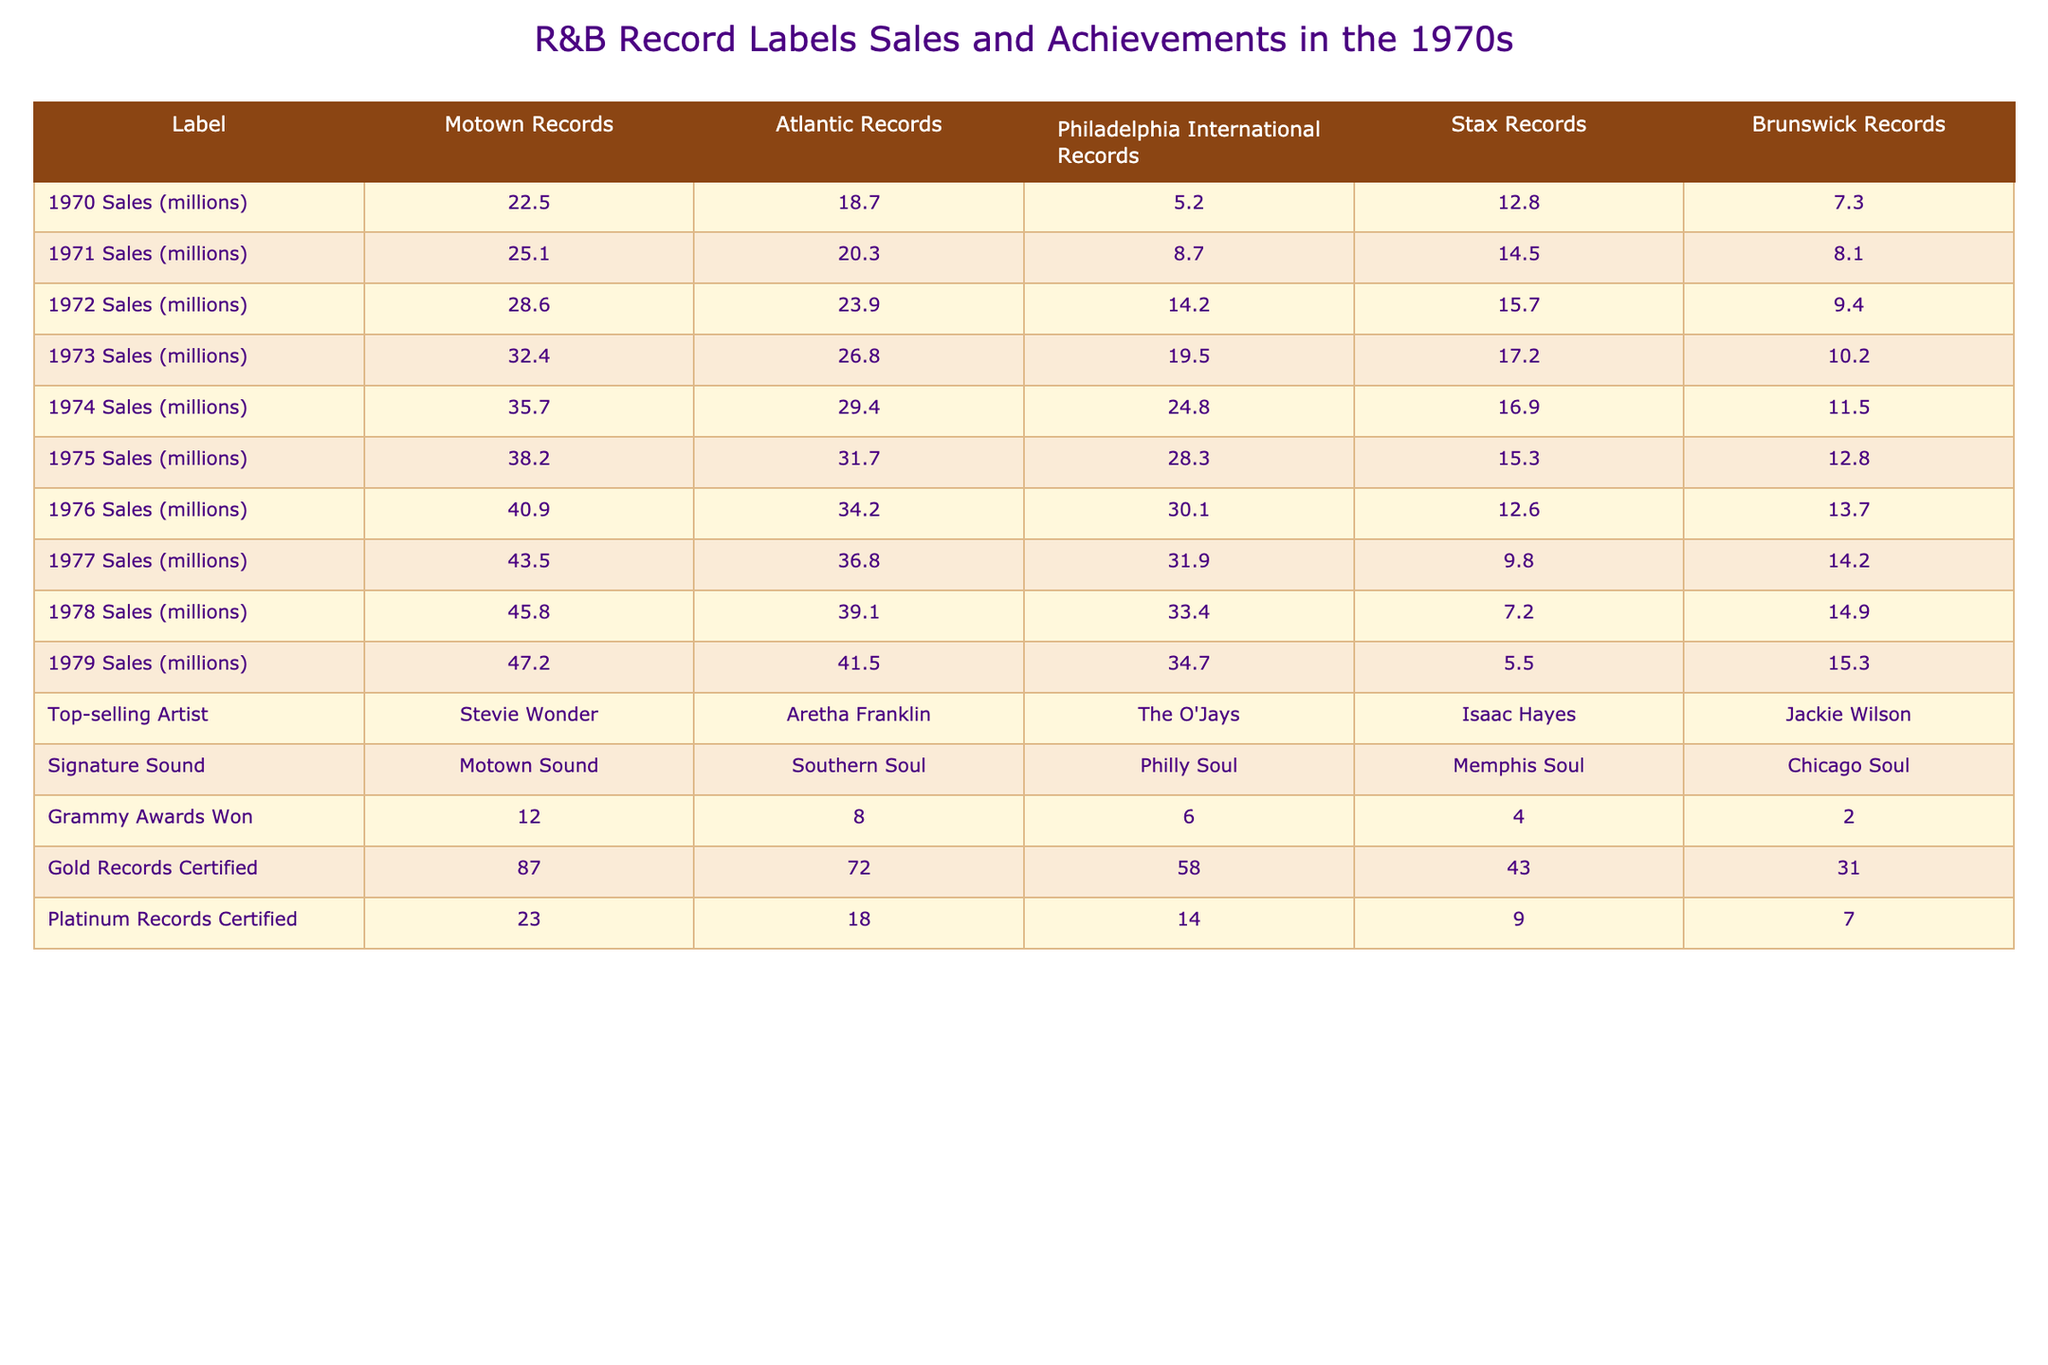What was the highest record sales for Motown Records in the 1970s? The highest annual sales figure for Motown Records was in 1979, with sales of 47.2 million.
Answer: 47.2 million Which label had the lowest sales in 1976? In 1976, Stax Records had the lowest sales compared to other labels, with 12.6 million.
Answer: Stax Records How many Grammy Awards did Atlantic Records win? Atlantic Records won a total of 8 Grammy Awards, as shown in the table.
Answer: 8 What was the difference in sales between Brunswick Records and Philadelphia International Records in 1975? In 1975, Brunswick Records had sales of 12.8 million while Philadelphia International Records had 28.3 million. The difference is 28.3 - 12.8 = 15.5 million.
Answer: 15.5 million What was the average sales figure for Atlantic Records over the decade? To find the average sales, we sum up the sales from 1970 to 1979 for Atlantic Records: (18.7 + 20.3 + 23.9 + 26.8 + 29.4 + 31.7 + 34.2 + 36.8 + 39.1 + 41.5) =  392.4 million. There are 10 years, so the average is 392.4/10 = 39.24 million.
Answer: 39.24 million Which record label had the highest number of Gold Records Certified? Motown Records had the highest number of Gold Records Certified, totaling 87.
Answer: Motown Records Did Philadelphia International Records have more Platinum Records Certified than Stax Records? Philadelphia International Records had 14 Platinum Records Certified, while Stax Records had 9. Therefore, yes, Philadelphia International had more.
Answer: Yes What was the trend of sales for Stax Records from 1970 to 1979? Reviewing the sales figures from 1970 (12.8 million) to 1979 (5.5 million), Stax Records' sales consistently decreased over the years.
Answer: Decreased How many Top-selling Artists are listed in the table, and who is the top seller among them? The table lists five top-selling artists across the record labels. The top seller is Stevie Wonder from Motown Records.
Answer: 5, Stevie Wonder What was the year when Atlantic Records first exceeded sales of 30 million? Atlantic Records exceeded sales of 30 million in 1975, achieving 31.7 million in that year.
Answer: 1975 Which label had the largest increase in sales between 1974 and 1975? The largest increase was with Motown Records, which grew from 35.7 million to 38.2 million, an increase of 2.5 million.
Answer: Motown Records 